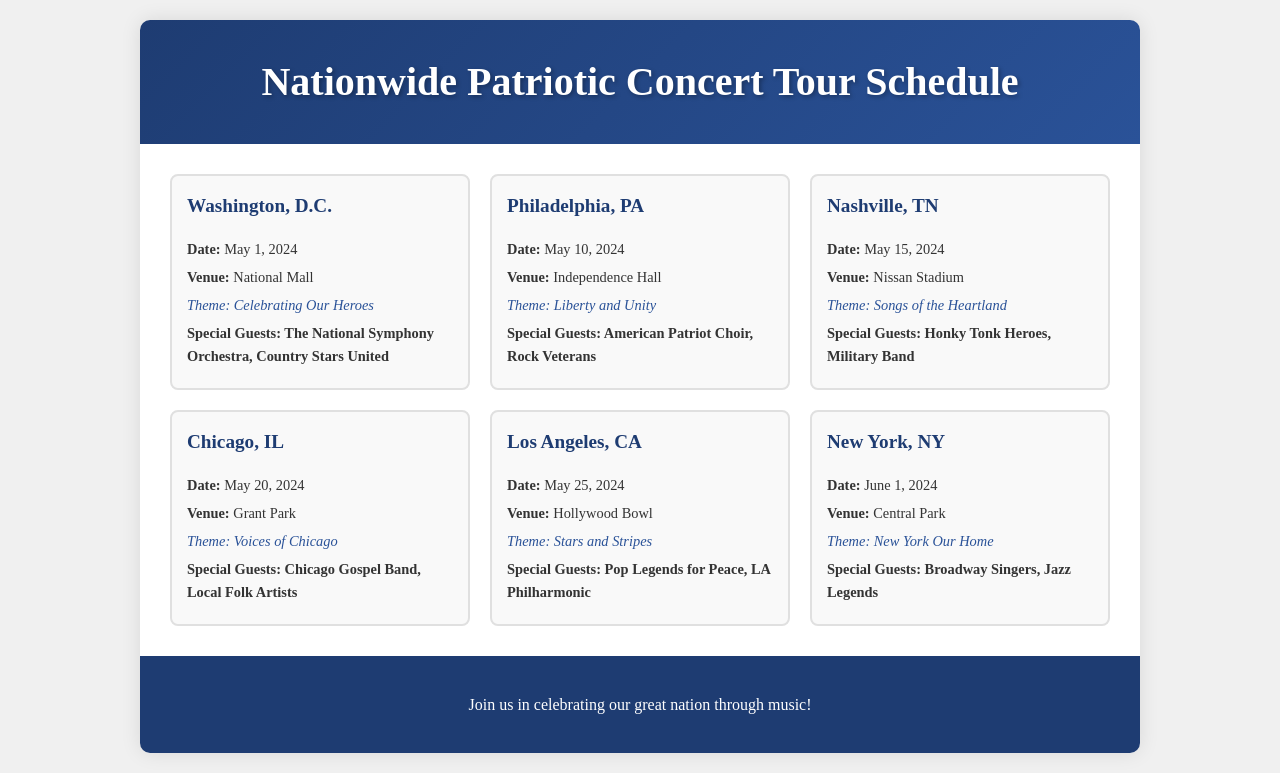What is the date of the concert in Washington, D.C.? The date of the concert in Washington, D.C. is mentioned in the schedule.
Answer: May 1, 2024 What venue is hosting the concert in Philadelphia, PA? The venue for the Philadelphia concert is indicated in the schedule.
Answer: Independence Hall Who are the special guests for the concert in Nashville, TN? The special guests for the Nashville concert are listed in the document.
Answer: Honky Tonk Heroes, Military Band What theme is associated with the concert in Los Angeles, CA? The theme of the Los Angeles concert is part of the event details provided.
Answer: Stars and Stripes Which city is hosting a concert on June 1, 2024? The city hosting a concert on this date can be found in the event schedule.
Answer: New York, NY How many concerts are featured in the schedule? The total number of concerts can be counted from the provided schedule.
Answer: Six Which special guests will perform in Chicago, IL? The special guests for the Chicago concert are noted in the event section.
Answer: Chicago Gospel Band, Local Folk Artists What is the theme for the concert in Washington, D.C.? The theme for this concert is stated in the corresponding event description.
Answer: Celebrating Our Heroes 